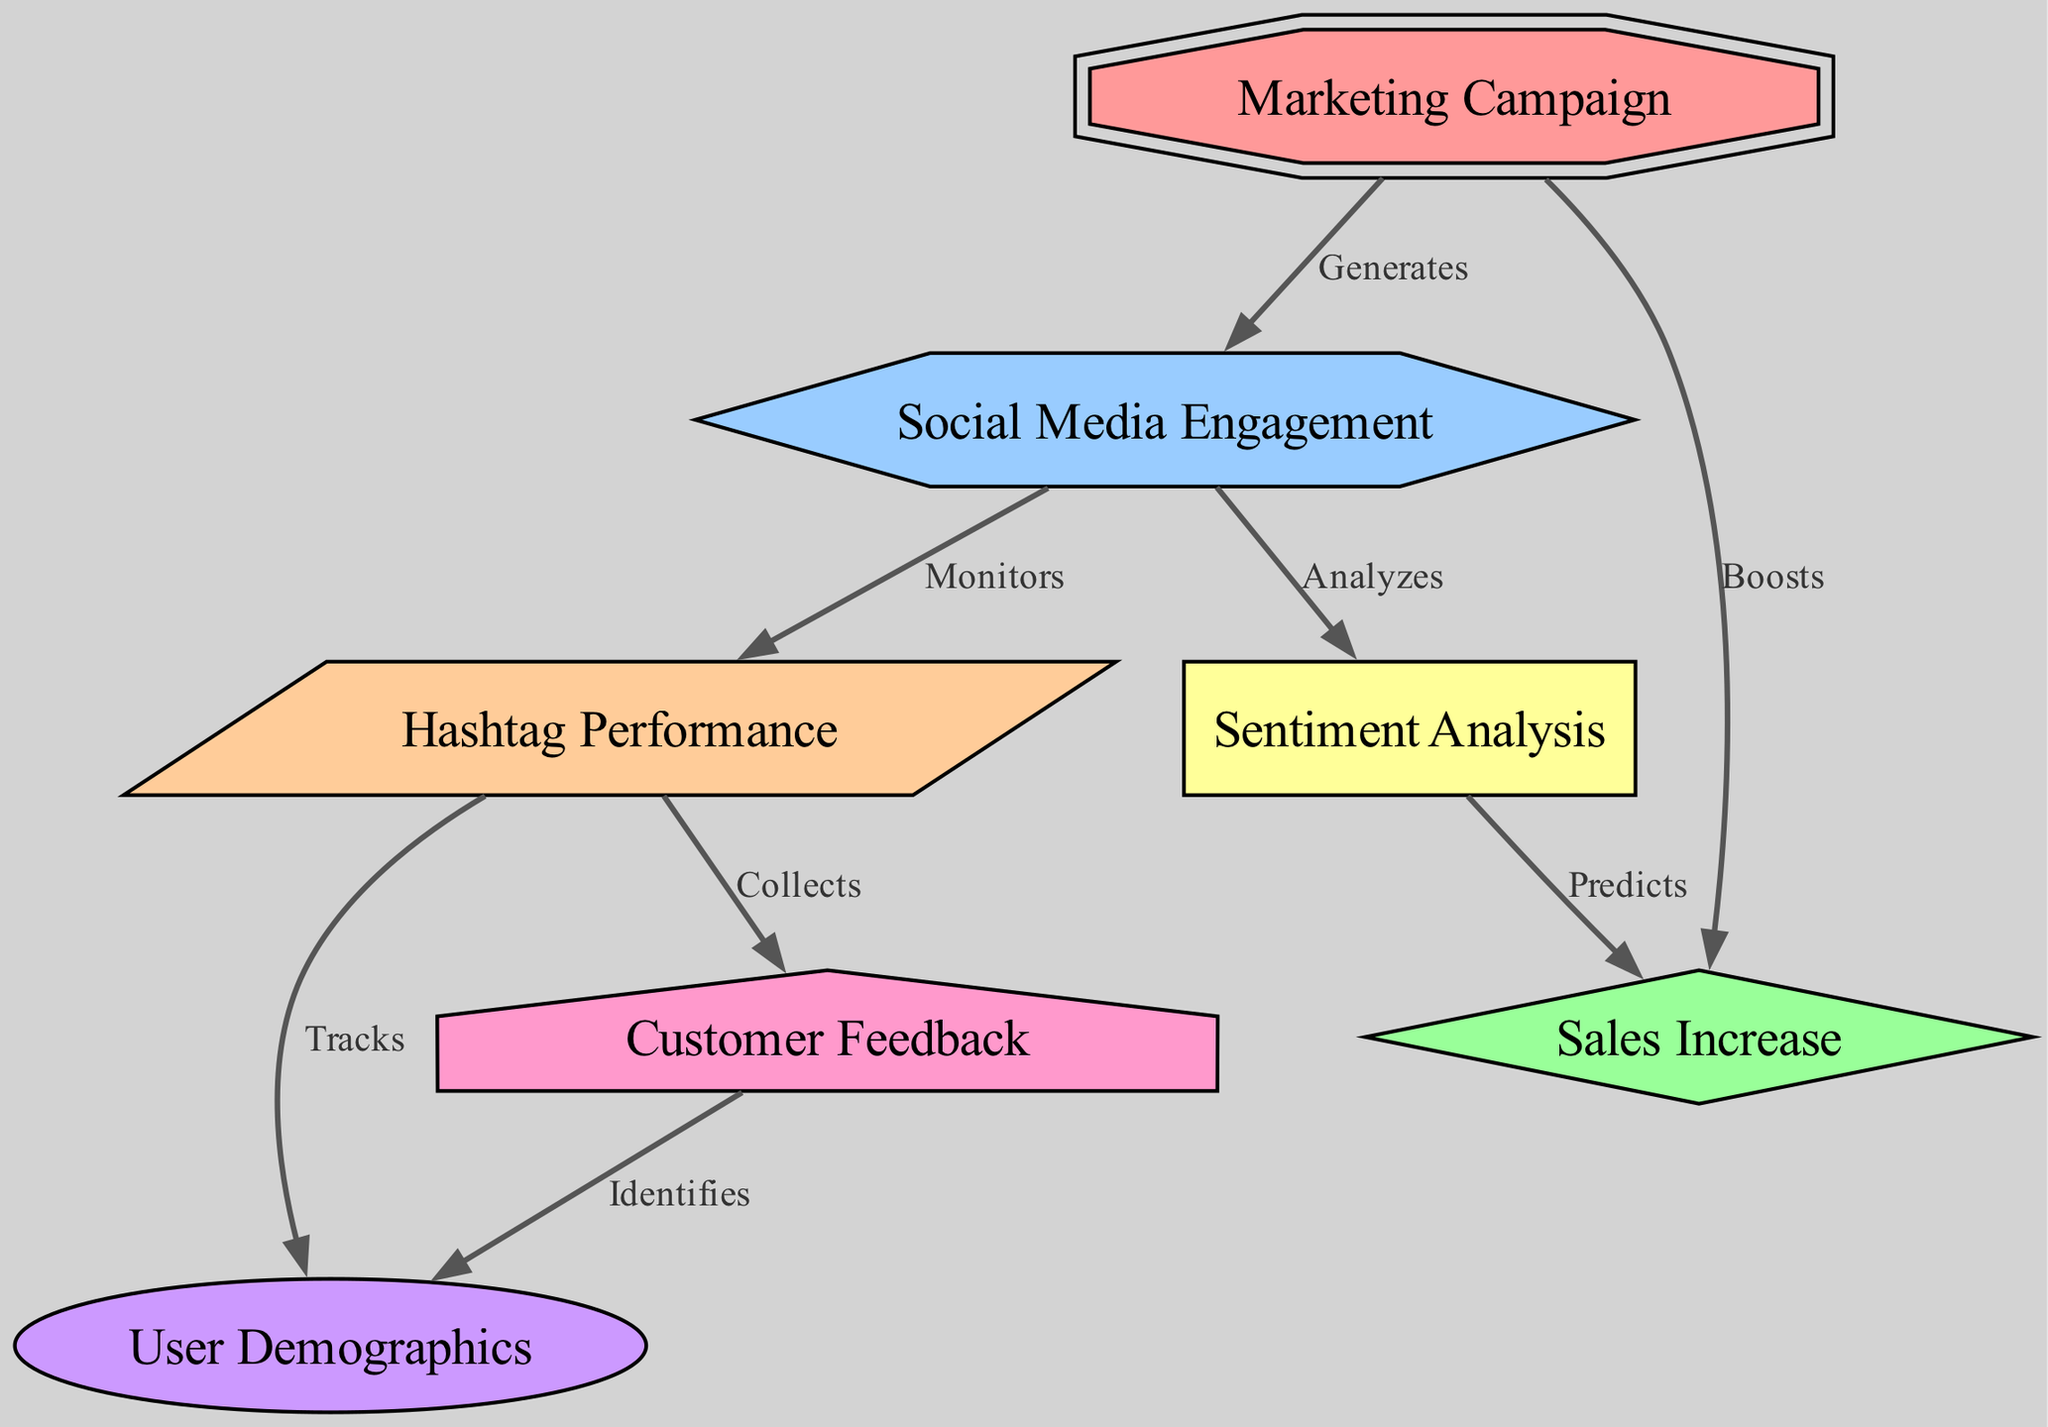What node generates social media engagement? The diagram shows a direct edge labeled "Generates" from the "Marketing Campaign" node (id: 1) to the "Social Media Engagement" node (id: 2). This indicates that the marketing campaign is responsible for generating social media engagement.
Answer: Marketing Campaign How many nodes are in the diagram? The total number of nodes listed in the data is seven, which can be counted directly from the "nodes" section.
Answer: 7 What does social media engagement monitor? In the diagram, there is an edge labeled "Monitors" from the "Social Media Engagement" node (id: 2) to the "Hashtag Performance" node (id: 4). This means social media engagement is responsible for monitoring hashtag performance.
Answer: Hashtag Performance Which node collects user demographics? The "User Demographics" node (id: 5) is linked to the "Hashtag Performance" node (id: 4) with an edge labeled "Tracks". However, it is the "Customer Feedback" node (id: 7) that collects user demographics, as determined by the relationship indicated in the diagram with the "Collects" label.
Answer: Customer Feedback What predicts sales increase? Analyzing the connections in the diagram, the "Sentiment Analysis" node (id: 6) has an edge labeled "Predicts" leading to the "Sales Increase" node (id: 3). This indicates that sentiment analysis is used to predict sales increases after the campaign.
Answer: Sentiment Analysis What relationships exist between customer feedback and user demographics? The diagram shows a relationship between "Customer Feedback" (id: 7) and "User Demographics" (id: 5) via an edge labeled "Identifies". This means that customer feedback helps to identify user demographics.
Answer: Identifies What boosts sales increase? The edge labeled "Boosts" connects the "Marketing Campaign" node (id: 1) to the "Sales Increase" node (id: 3), indicating that the marketing campaign boosts sales increase through its activities.
Answer: Marketing Campaign What does social media engagement analyze? According to the diagram, the "Social Media Engagement" node (id: 2) has an edge labeled "Analyzes" connected to the "Sentiment Analysis" node (id: 6). This means that social media engagement is responsible for analyzing sentiment.
Answer: Sentiment Analysis 